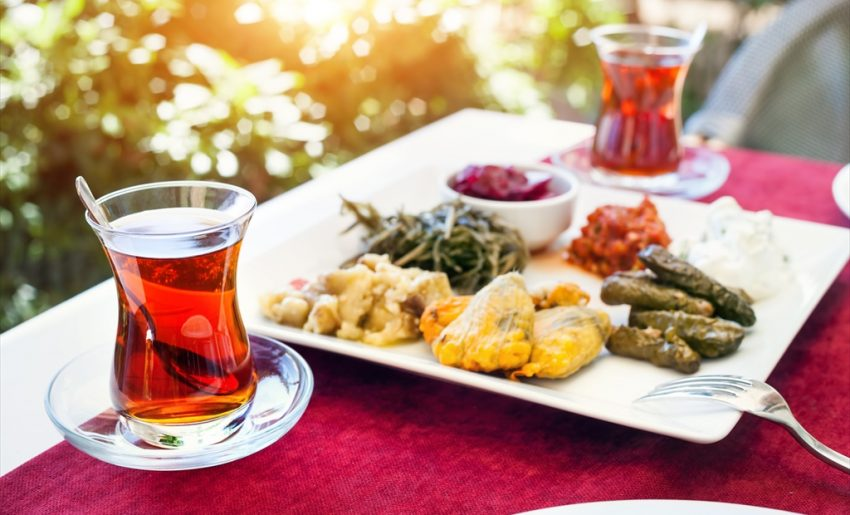Could you describe each of the components seen on the plate in more detail? Certainly! Starting from the top left corner, there's a pile of pickled red cabbage which provides a tangy flavor. Next to it, the bright red spread is likely a roasted red pepper paste, which is rich and sweet. The white, creamy spread is a yogurt-based dip, offering a cool, refreshing taste. Below that are the stuffed grape leaves, filled with a mixture of rice and herbs, a classic dolma. The golden brown item might be a piece of fried fish or chicken, providing a crispy, savory element. On the bottom right, the pale green item looks like sauteed greens, possibly spinach or a similar leafy vegetable, adding an earthy component. 